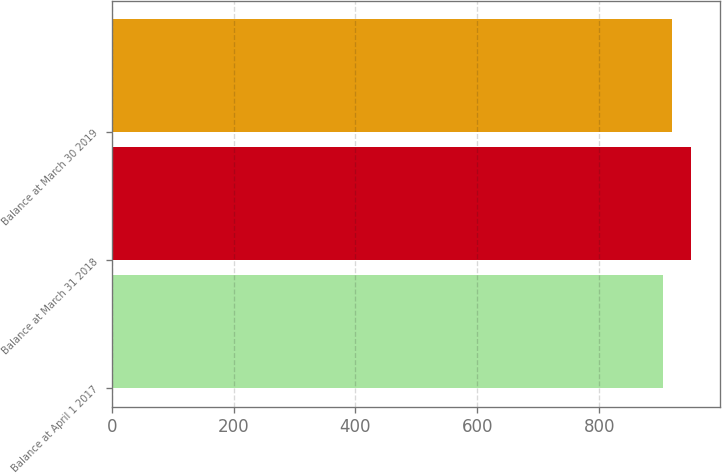Convert chart to OTSL. <chart><loc_0><loc_0><loc_500><loc_500><bar_chart><fcel>Balance at April 1 2017<fcel>Balance at March 31 2018<fcel>Balance at March 30 2019<nl><fcel>904.6<fcel>950.5<fcel>919.6<nl></chart> 